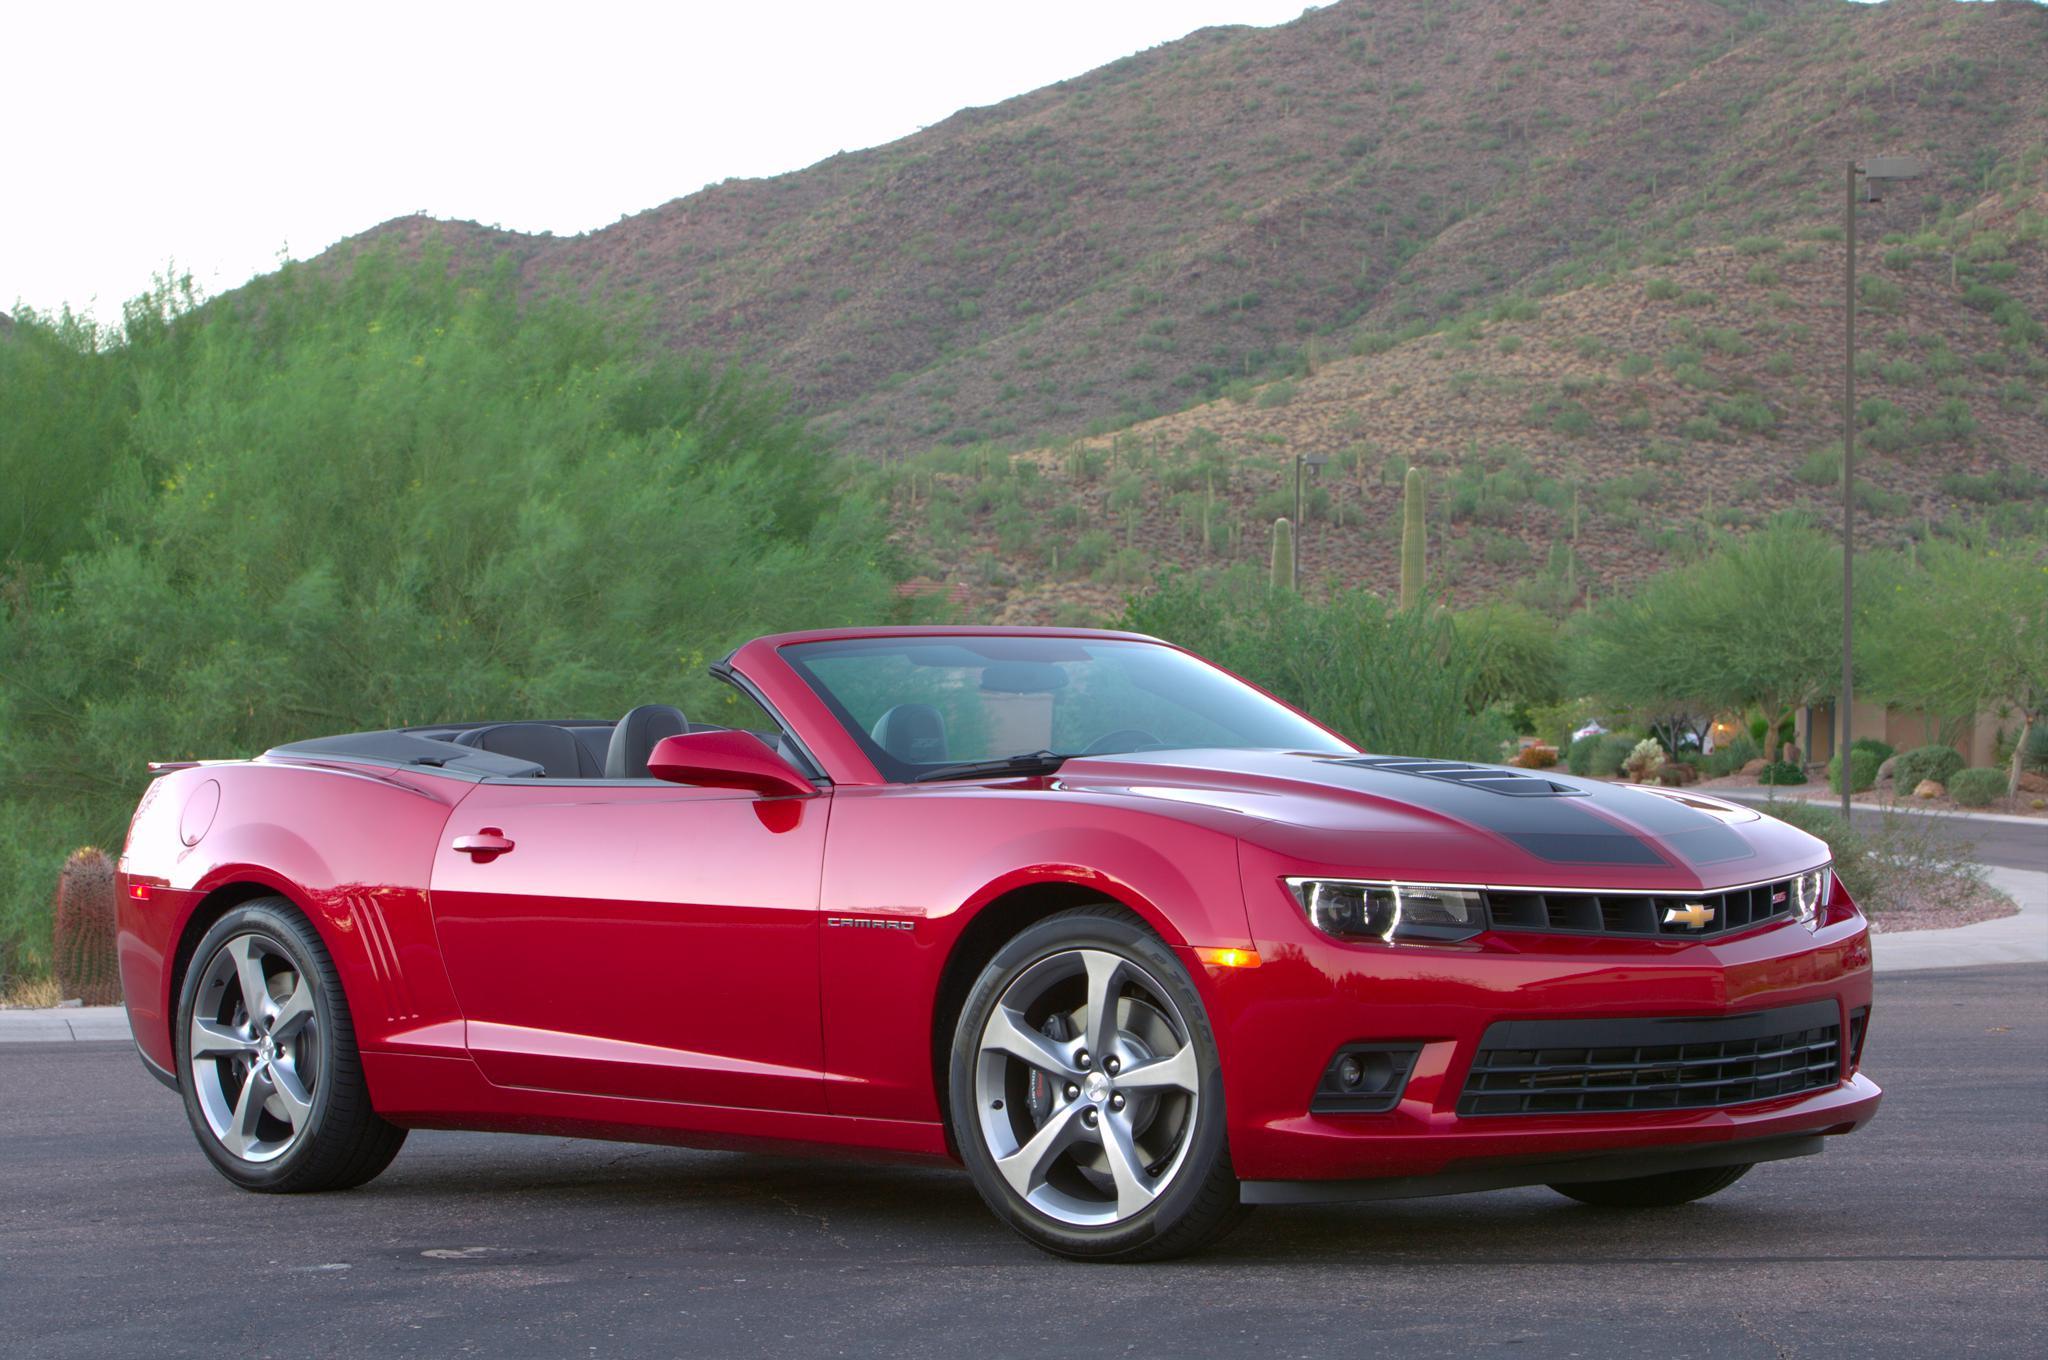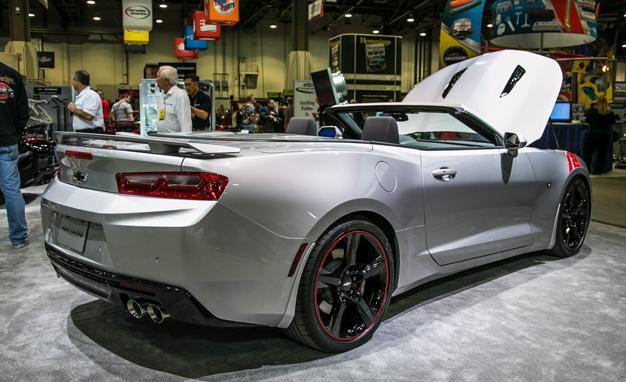The first image is the image on the left, the second image is the image on the right. Given the left and right images, does the statement "Two convertibles of different makes and colors, with tops down, are being driven on open roads with no other visible traffic." hold true? Answer yes or no. No. The first image is the image on the left, the second image is the image on the right. Evaluate the accuracy of this statement regarding the images: "All cars are photographed with a blurry background as if they are moving.". Is it true? Answer yes or no. No. 